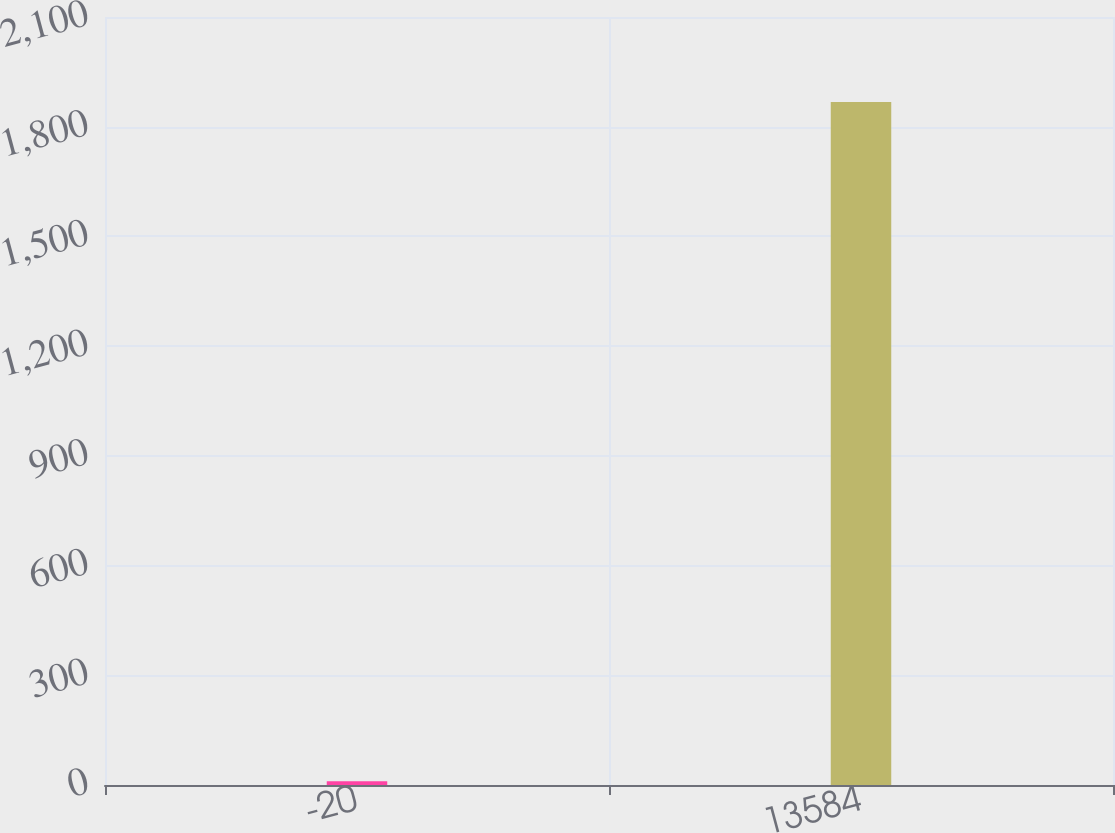Convert chart to OTSL. <chart><loc_0><loc_0><loc_500><loc_500><bar_chart><fcel>-20<fcel>13584<nl><fcel>10<fcel>1867.8<nl></chart> 